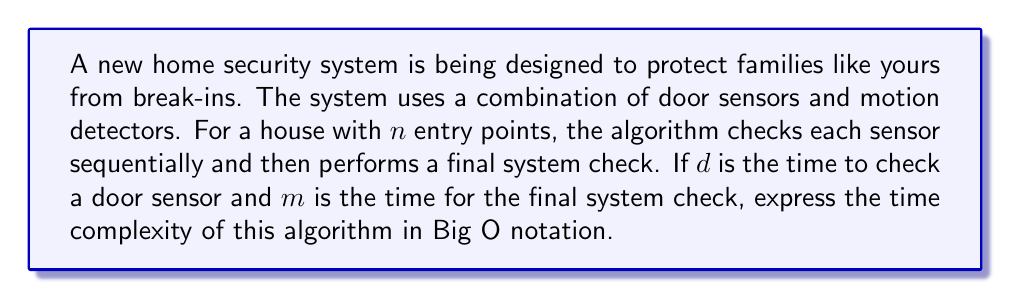Solve this math problem. To analyze the time complexity of this home security system algorithm, let's break it down step by step:

1. Door sensor checks:
   - There are $n$ entry points, each with a sensor.
   - Each sensor check takes $d$ time.
   - Total time for sensor checks: $n \cdot d$

2. Final system check:
   - This is performed once after all sensor checks.
   - It takes $m$ time.

3. Total time for the algorithm:
   $T(n) = n \cdot d + m$

4. Big O analysis:
   - $n \cdot d$ is a linear term in $n$.
   - $m$ is a constant term.
   - In Big O notation, we focus on the dominant term as $n$ grows large and ignore constant factors.

5. As $n$ increases, the $n \cdot d$ term will dominate over the constant $m$.

6. Therefore, we can simplify the time complexity to $O(n)$, dropping the constant factor $d$.

This linear time complexity means that the time taken by the algorithm grows proportionally with the number of entry points, which is efficient and scalable for homes of various sizes.
Answer: $O(n)$ 